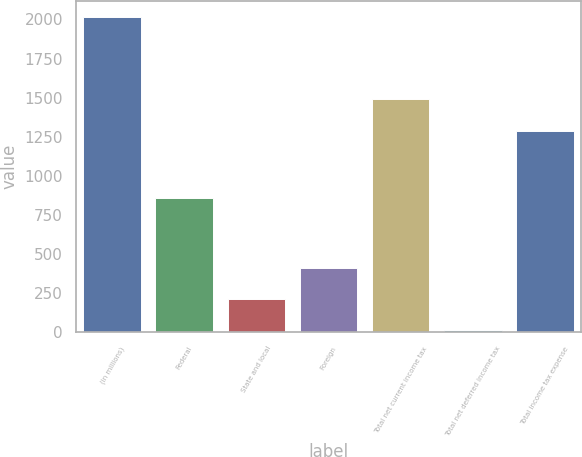Convert chart to OTSL. <chart><loc_0><loc_0><loc_500><loc_500><bar_chart><fcel>(in millions)<fcel>Federal<fcel>State and local<fcel>Foreign<fcel>Total net current income tax<fcel>Total net deferred income tax<fcel>Total income tax expense<nl><fcel>2016<fcel>858<fcel>214.2<fcel>414.4<fcel>1490.2<fcel>14<fcel>1290<nl></chart> 